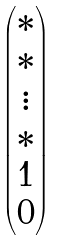<formula> <loc_0><loc_0><loc_500><loc_500>\begin{pmatrix} * \\ * \\ \vdots \\ * \\ 1 \\ 0 \end{pmatrix}</formula> 